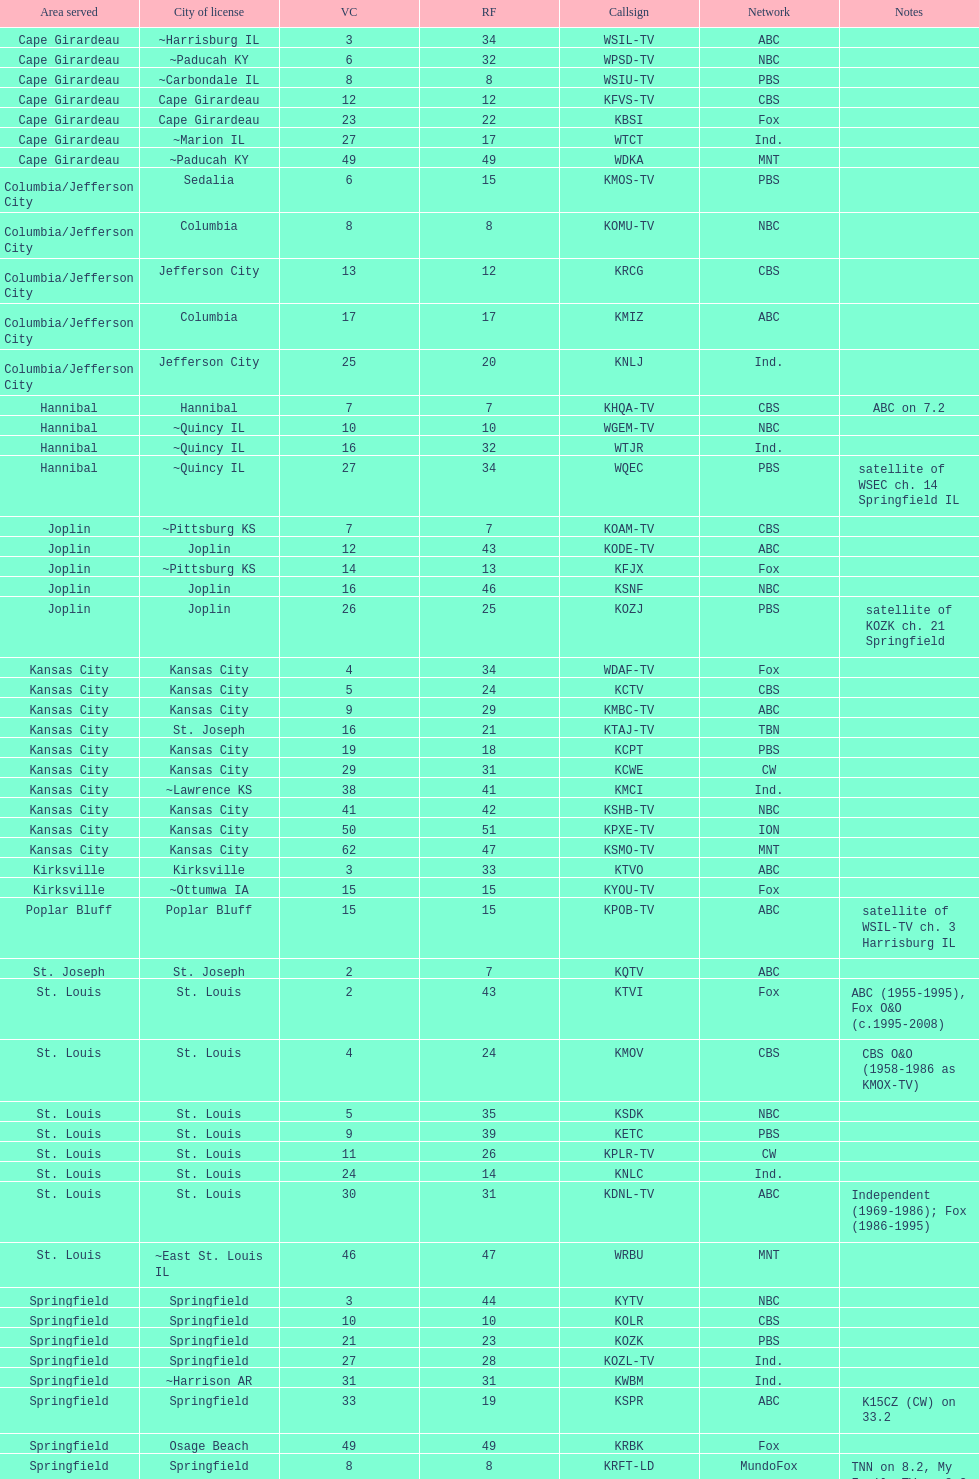How many of these missouri television stations are truly licensed in a city in illinois (il)? 7. 